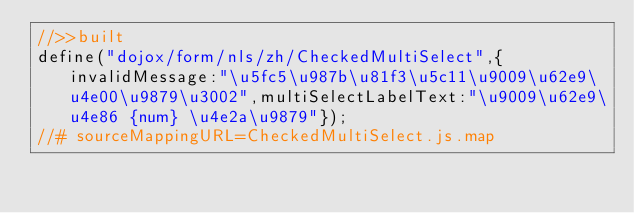Convert code to text. <code><loc_0><loc_0><loc_500><loc_500><_JavaScript_>//>>built
define("dojox/form/nls/zh/CheckedMultiSelect",{invalidMessage:"\u5fc5\u987b\u81f3\u5c11\u9009\u62e9\u4e00\u9879\u3002",multiSelectLabelText:"\u9009\u62e9\u4e86 {num} \u4e2a\u9879"});
//# sourceMappingURL=CheckedMultiSelect.js.map</code> 